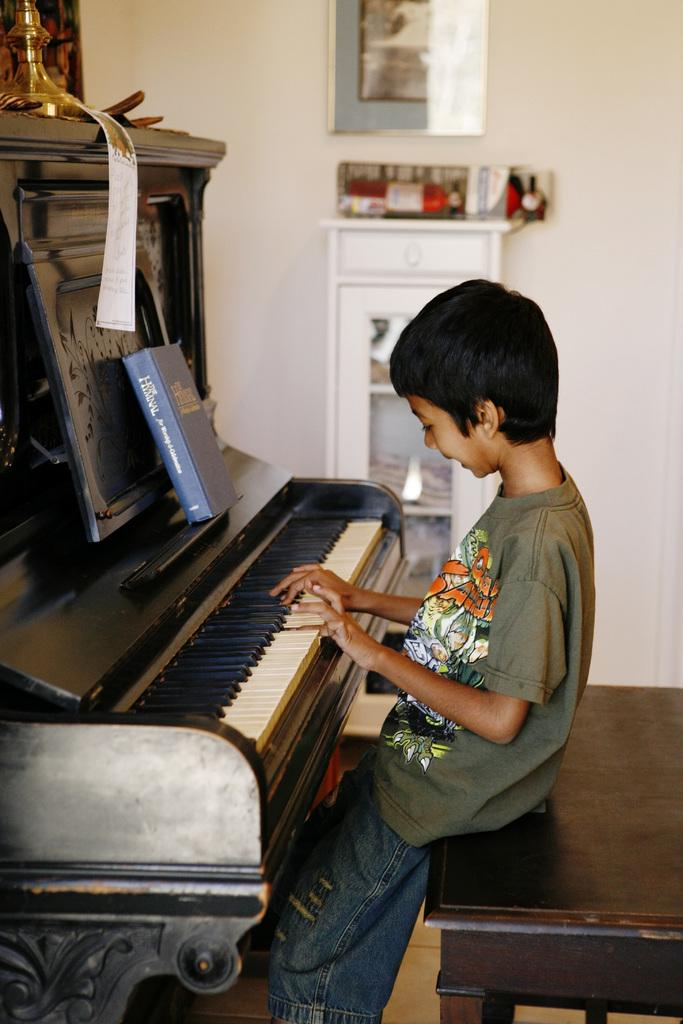Who is the main subject in the image? There is a boy in the image. What is the boy doing in the image? The boy is sitting on a table and playing a piano. Are there any objects on the piano? Yes, there is a book and a paper on the piano. What can be seen in the background of the image? There is a cupboard with racks and frames on the wall in the background. How many men are visible in the image? There are no men visible in the image; only a boy is present. Can you tell me what type of goldfish is swimming in the piano? There are no goldfish present in the image; it features a boy playing a piano with a book and a paper on it. 